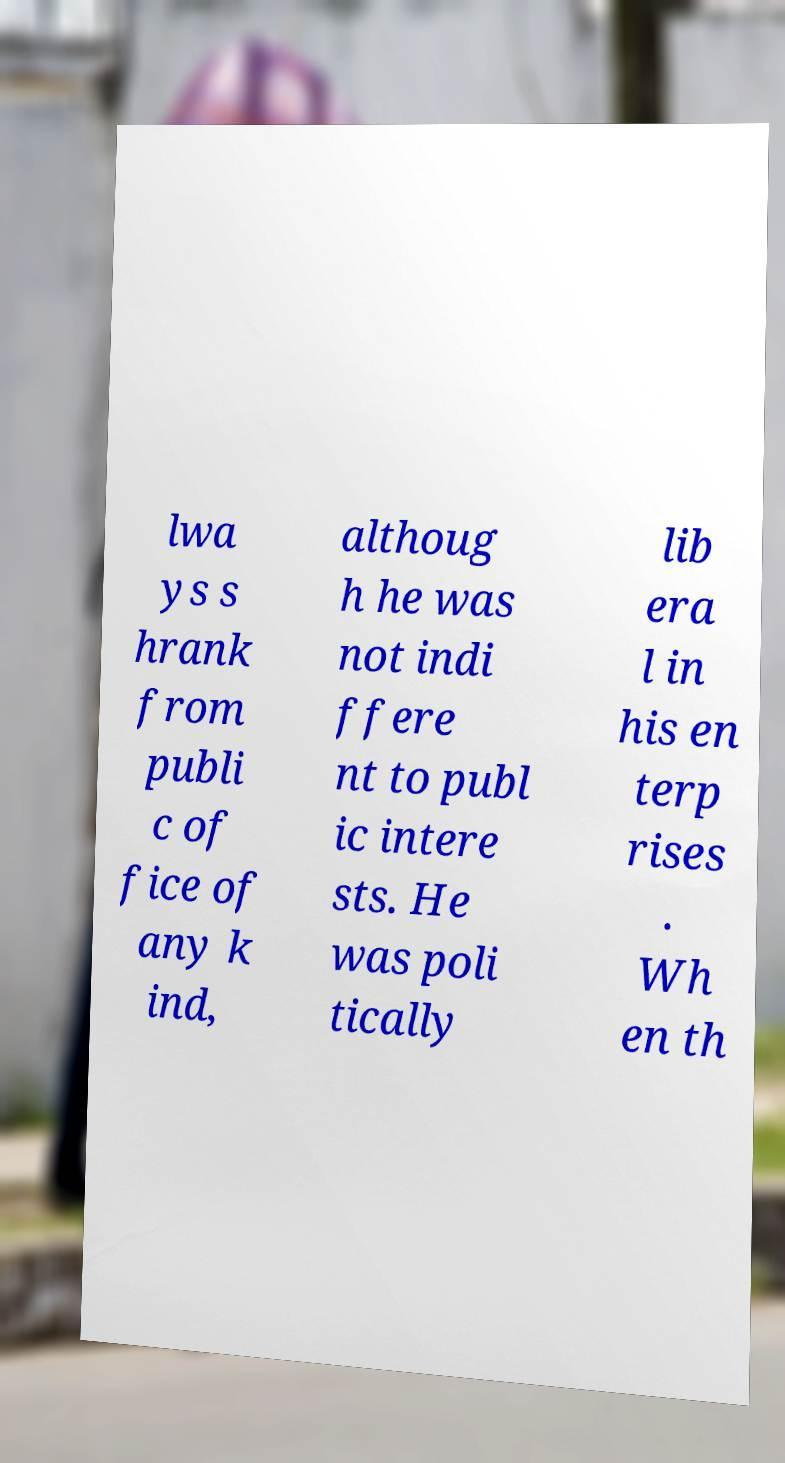Could you extract and type out the text from this image? lwa ys s hrank from publi c of fice of any k ind, althoug h he was not indi ffere nt to publ ic intere sts. He was poli tically lib era l in his en terp rises . Wh en th 